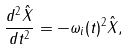Convert formula to latex. <formula><loc_0><loc_0><loc_500><loc_500>\frac { d ^ { 2 } \hat { X } } { d t ^ { 2 } } = - \omega _ { i } ( t ) ^ { 2 } \hat { X } ,</formula> 